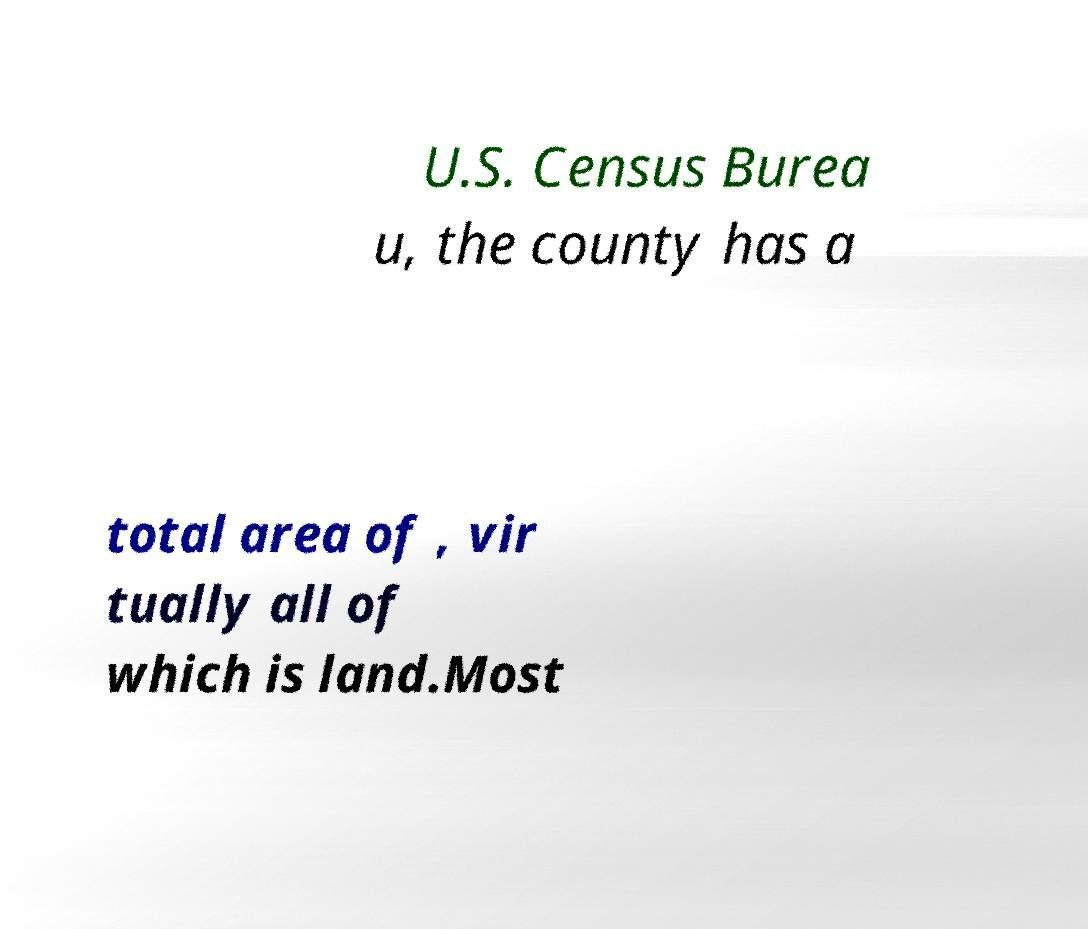Could you extract and type out the text from this image? U.S. Census Burea u, the county has a total area of , vir tually all of which is land.Most 